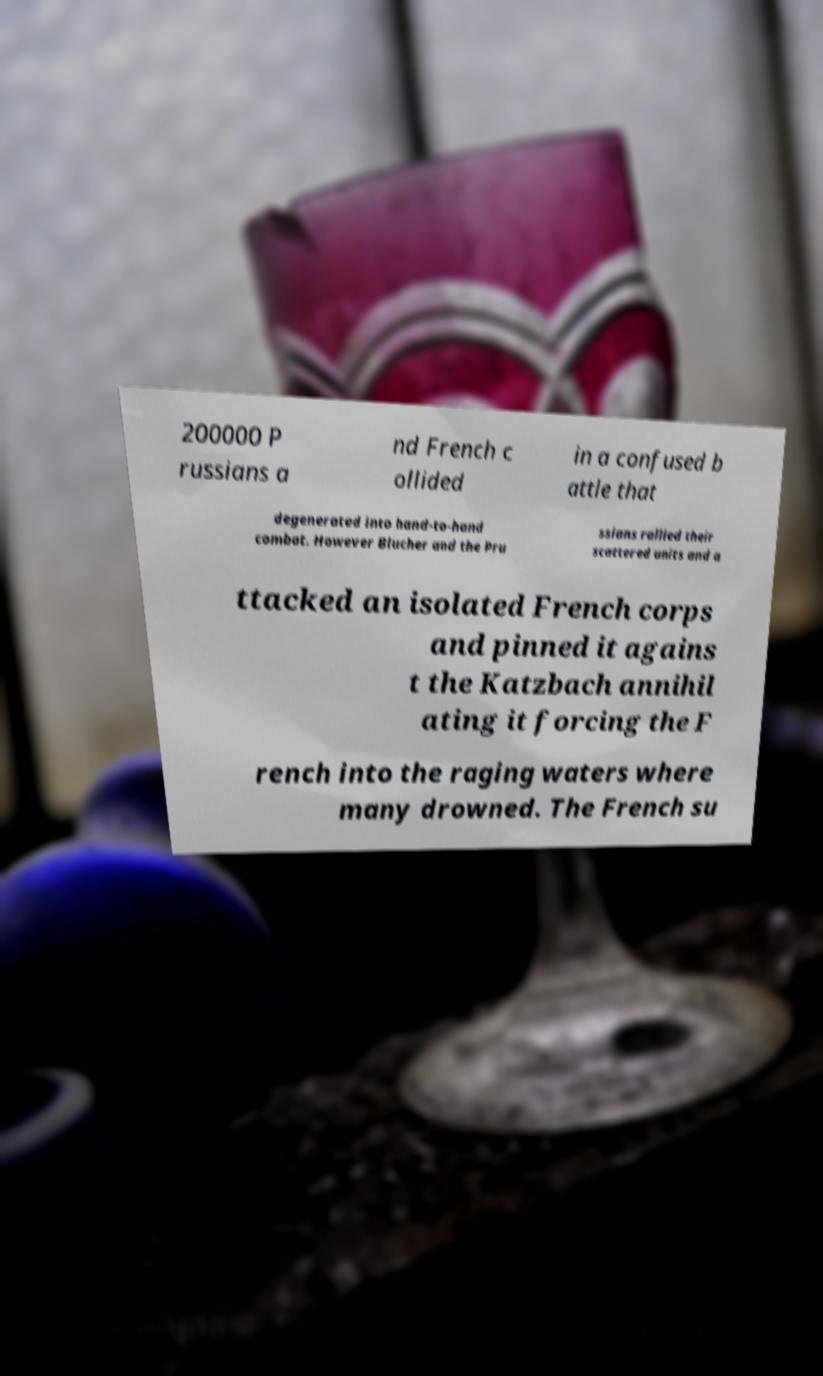There's text embedded in this image that I need extracted. Can you transcribe it verbatim? 200000 P russians a nd French c ollided in a confused b attle that degenerated into hand-to-hand combat. However Blucher and the Pru ssians rallied their scattered units and a ttacked an isolated French corps and pinned it agains t the Katzbach annihil ating it forcing the F rench into the raging waters where many drowned. The French su 